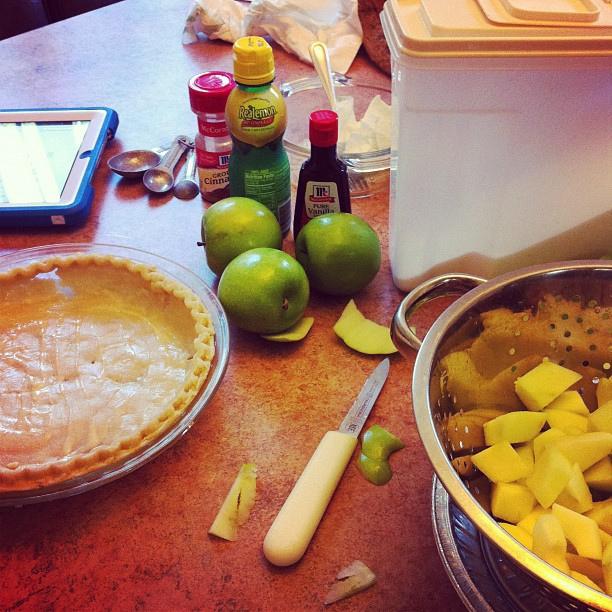Is this a healthy lunch?
Answer briefly. No. Why are the cooked foods shiny?
Give a very brief answer. Butter. What utensil is in the photo?
Quick response, please. Knife. Is this dish vegan?
Concise answer only. Yes. What color is the knife handle?
Be succinct. Yellow. What kind of seasoning was used?
Write a very short answer. Cinnamon. Are there a set of keys in this picture?
Be succinct. No. Which fruit can be sliced in half and juiced?
Answer briefly. Apple. What is the holiday coming up?
Answer briefly. Thanksgiving. Does this look like a healthy meal?
Quick response, please. No. How many spice jars are there?
Keep it brief. 1. What color is the bottle cap?
Quick response, please. Red. Are there pineapples in this photo?
Keep it brief. No. What color is the pans handle?
Quick response, please. Silver. Will the chef cook these together?
Short answer required. Yes. Which utensils are visible?
Quick response, please. Knife. What is in the silver bowl?
Be succinct. Fruit. What kind of fruit is on the table?
Keep it brief. Apples. Does the pie crust have a fluted edge?
Give a very brief answer. Yes. What color are the fruits?
Short answer required. Green. What are the yellow items?
Quick response, please. Apples. Are these veggies?
Be succinct. No. What is the orange food?
Answer briefly. Pie. What will the ingredients make together?
Quick response, please. Pie. What is in the bottles above the produce?
Quick response, please. Lemon juice. Are the vegetables chopped or sliced?
Be succinct. Chopped. Which color is dominant in the photo?
Write a very short answer. Yellow. What kind of pie is being made?
Short answer required. Apple. What is the container made of?
Short answer required. Plastic. What kind of nut is in the silver bowl?
Keep it brief. None. Is the green apple edible?
Be succinct. Yes. What color is the pie pan?
Give a very brief answer. Clear. Is the place clean?
Give a very brief answer. No. Where is the glass of water?
Quick response, please. On table. What is the color of the apples?
Short answer required. Green. What is the green object called?
Concise answer only. Apple. What color are apples?
Short answer required. Green. What fruit item appears in this picture?
Quick response, please. Apple. Which fruit are yellow?
Write a very short answer. Mango. Is there a fork or a spoon in the vegetables?
Quick response, please. Neither. Two hand Two utensils working on a table?
Write a very short answer. No. Are these glazed apples?
Quick response, please. No. Are the fruits been sold?
Quick response, please. No. Are the apples going to be cooked?
Quick response, please. Yes. How many apples are there?
Write a very short answer. 3. How many of these fruits can be eaten without removing the peel?
Answer briefly. 3. How many donuts are pictured?
Quick response, please. 0. What dairy products?
Keep it brief. None. What type of pie does it look like they are making?
Keep it brief. Apple. What is in the small bowl to the right?
Concise answer only. Apples. Are the limes in the photos whole or sliced?
Keep it brief. Whole. 